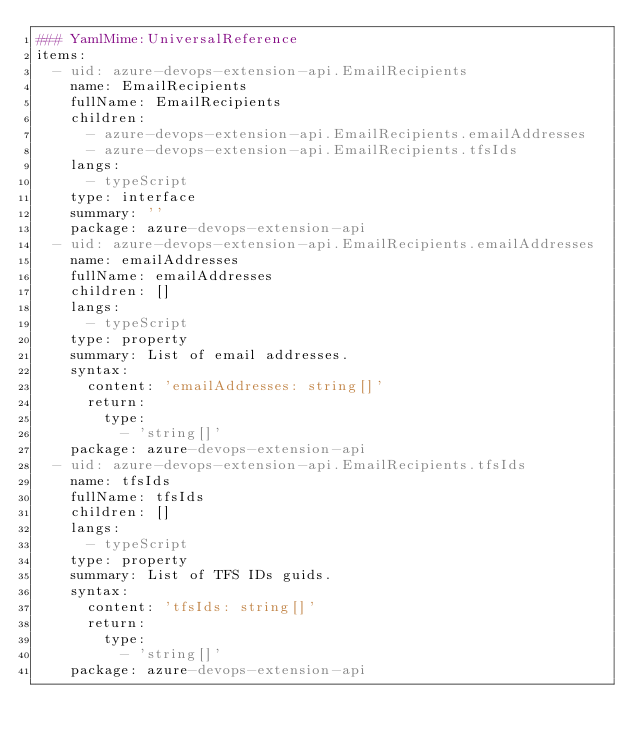Convert code to text. <code><loc_0><loc_0><loc_500><loc_500><_YAML_>### YamlMime:UniversalReference
items:
  - uid: azure-devops-extension-api.EmailRecipients
    name: EmailRecipients
    fullName: EmailRecipients
    children:
      - azure-devops-extension-api.EmailRecipients.emailAddresses
      - azure-devops-extension-api.EmailRecipients.tfsIds
    langs:
      - typeScript
    type: interface
    summary: ''
    package: azure-devops-extension-api
  - uid: azure-devops-extension-api.EmailRecipients.emailAddresses
    name: emailAddresses
    fullName: emailAddresses
    children: []
    langs:
      - typeScript
    type: property
    summary: List of email addresses.
    syntax:
      content: 'emailAddresses: string[]'
      return:
        type:
          - 'string[]'
    package: azure-devops-extension-api
  - uid: azure-devops-extension-api.EmailRecipients.tfsIds
    name: tfsIds
    fullName: tfsIds
    children: []
    langs:
      - typeScript
    type: property
    summary: List of TFS IDs guids.
    syntax:
      content: 'tfsIds: string[]'
      return:
        type:
          - 'string[]'
    package: azure-devops-extension-api
</code> 